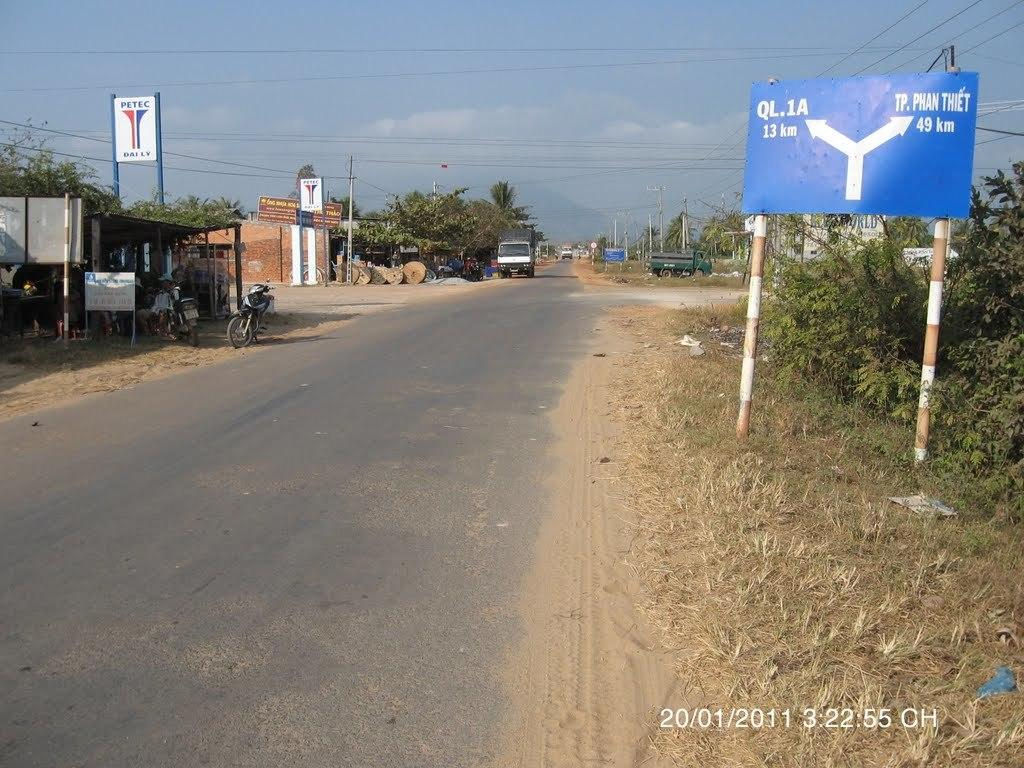<image>
Provide a brief description of the given image. A dirty road has a blue sign next to it that says TP. Phan Thiet 49 km. 